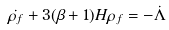<formula> <loc_0><loc_0><loc_500><loc_500>\dot { \rho _ { f } } + 3 ( \beta + 1 ) H \rho _ { f } = - \dot { \Lambda }</formula> 